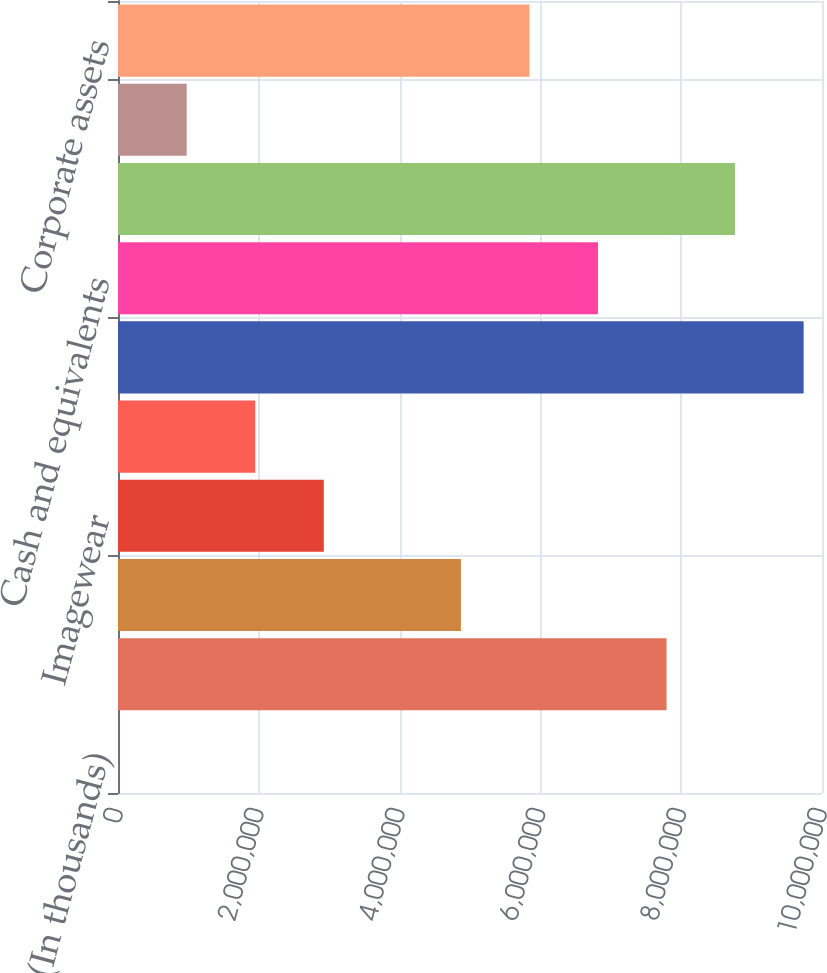<chart> <loc_0><loc_0><loc_500><loc_500><bar_chart><fcel>(In thousands)<fcel>Outdoor & Action Sports<fcel>Jeanswear<fcel>Imagewear<fcel>Other<fcel>Total coalition assets<fcel>Cash and equivalents<fcel>Intangible assets and goodwill<fcel>Deferred income taxes<fcel>Corporate assets<nl><fcel>2016<fcel>7.79183e+06<fcel>4.87065e+06<fcel>2.9232e+06<fcel>1.94947e+06<fcel>9.73929e+06<fcel>6.81811e+06<fcel>8.76556e+06<fcel>975743<fcel>5.84438e+06<nl></chart> 